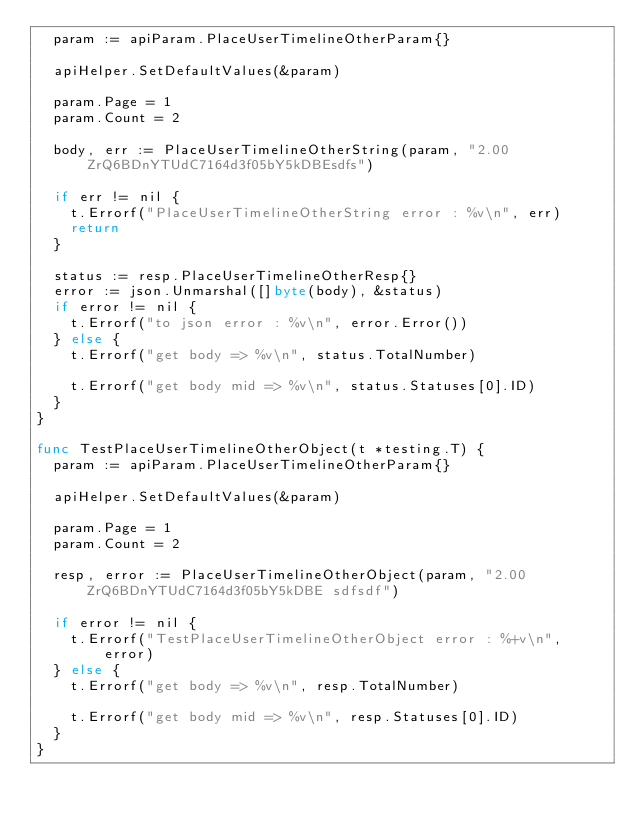Convert code to text. <code><loc_0><loc_0><loc_500><loc_500><_Go_>	param := apiParam.PlaceUserTimelineOtherParam{}

	apiHelper.SetDefaultValues(&param)

	param.Page = 1
	param.Count = 2

	body, err := PlaceUserTimelineOtherString(param, "2.00ZrQ6BDnYTUdC7164d3f05bY5kDBEsdfs")

	if err != nil {
		t.Errorf("PlaceUserTimelineOtherString error : %v\n", err)
		return
	}

	status := resp.PlaceUserTimelineOtherResp{}
	error := json.Unmarshal([]byte(body), &status)
	if error != nil {
		t.Errorf("to json error : %v\n", error.Error())
	} else {
		t.Errorf("get body => %v\n", status.TotalNumber)

		t.Errorf("get body mid => %v\n", status.Statuses[0].ID)
	}
}

func TestPlaceUserTimelineOtherObject(t *testing.T) {
	param := apiParam.PlaceUserTimelineOtherParam{}

	apiHelper.SetDefaultValues(&param)

	param.Page = 1
	param.Count = 2

	resp, error := PlaceUserTimelineOtherObject(param, "2.00ZrQ6BDnYTUdC7164d3f05bY5kDBE sdfsdf")

	if error != nil {
		t.Errorf("TestPlaceUserTimelineOtherObject error : %+v\n", error)
	} else {
		t.Errorf("get body => %v\n", resp.TotalNumber)

		t.Errorf("get body mid => %v\n", resp.Statuses[0].ID)
	}
}
</code> 